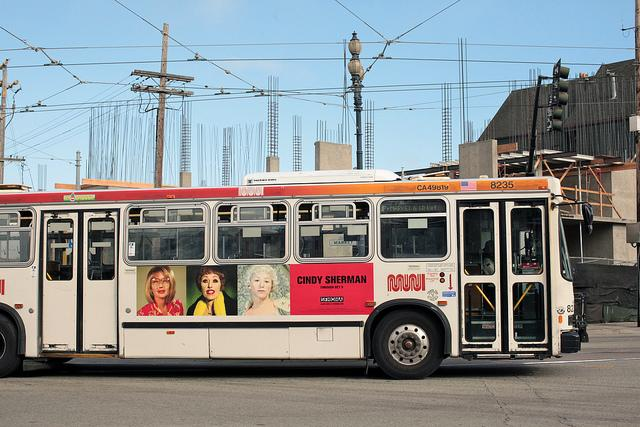What is on the side of the bus? Please explain your reasoning. advertisement. It is showing information for a current local art exhibit. 